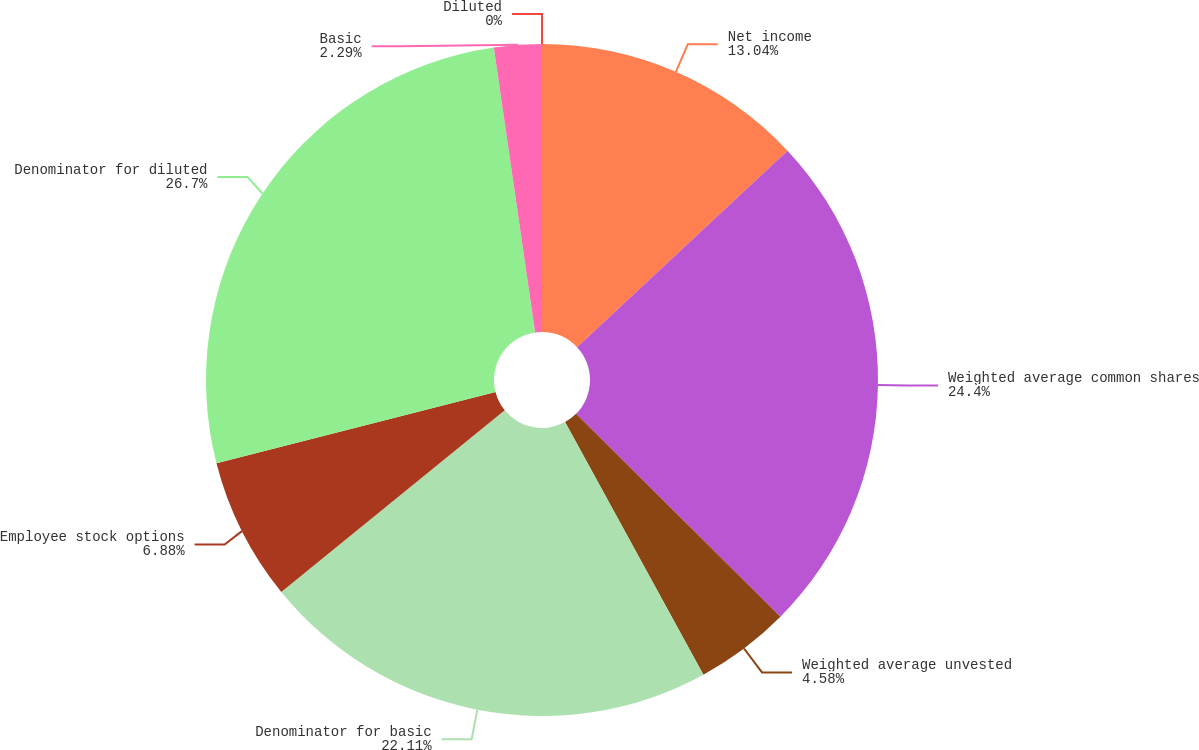Convert chart to OTSL. <chart><loc_0><loc_0><loc_500><loc_500><pie_chart><fcel>Net income<fcel>Weighted average common shares<fcel>Weighted average unvested<fcel>Denominator for basic<fcel>Employee stock options<fcel>Denominator for diluted<fcel>Basic<fcel>Diluted<nl><fcel>13.04%<fcel>24.4%<fcel>4.58%<fcel>22.11%<fcel>6.88%<fcel>26.69%<fcel>2.29%<fcel>0.0%<nl></chart> 